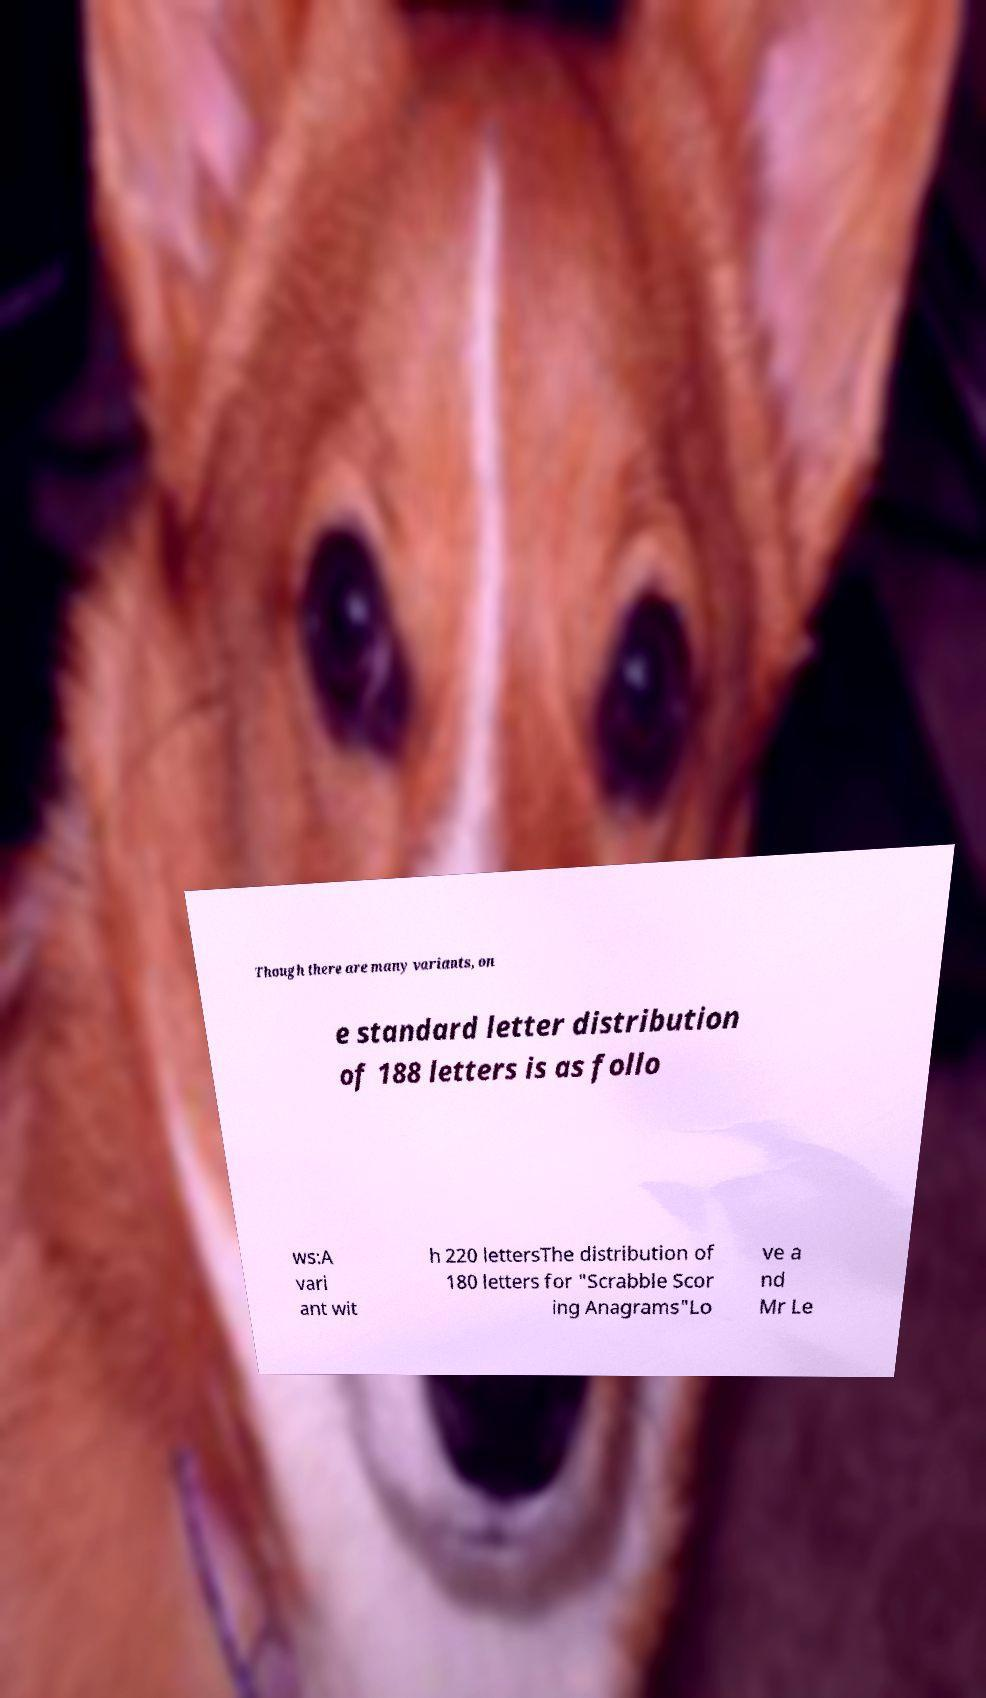Could you extract and type out the text from this image? Though there are many variants, on e standard letter distribution of 188 letters is as follo ws:A vari ant wit h 220 lettersThe distribution of 180 letters for "Scrabble Scor ing Anagrams"Lo ve a nd Mr Le 